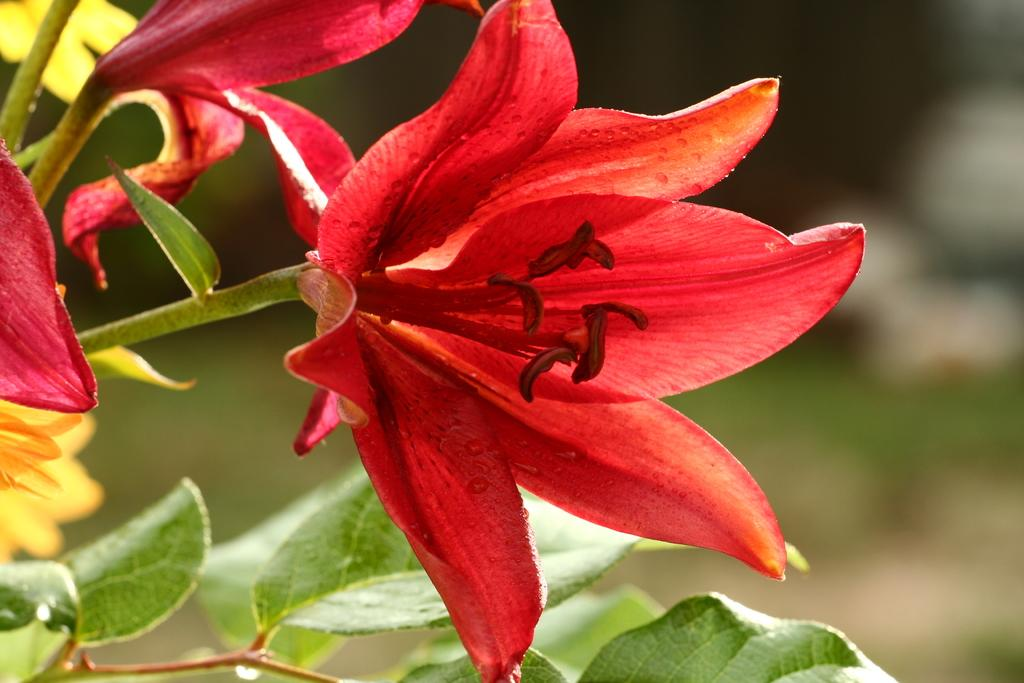What type of living organisms can be seen in the image? Plants can be seen in the image. What part of the plants is visible in the image? Leaves are visible in the image. Can you describe the background of the image? The background of the image is blurry. What type of voice can be heard coming from the plants in the image? There is no voice present in the image, as plants do not have the ability to produce or emit sounds. 